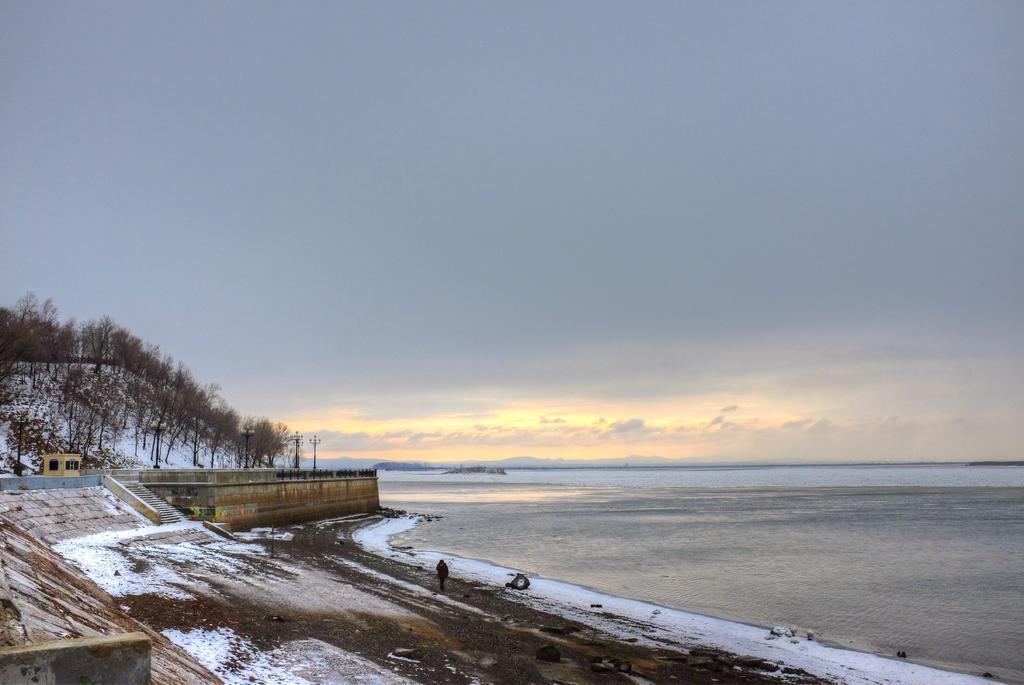Please provide a concise description of this image. In this picture we can see water, wall, trees and a person on the ground and in the background we can see sky with clouds. 